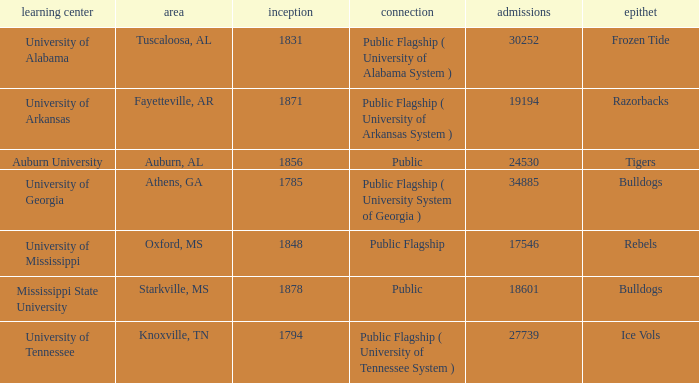What is the nickname of the University of Alabama? Frozen Tide. 